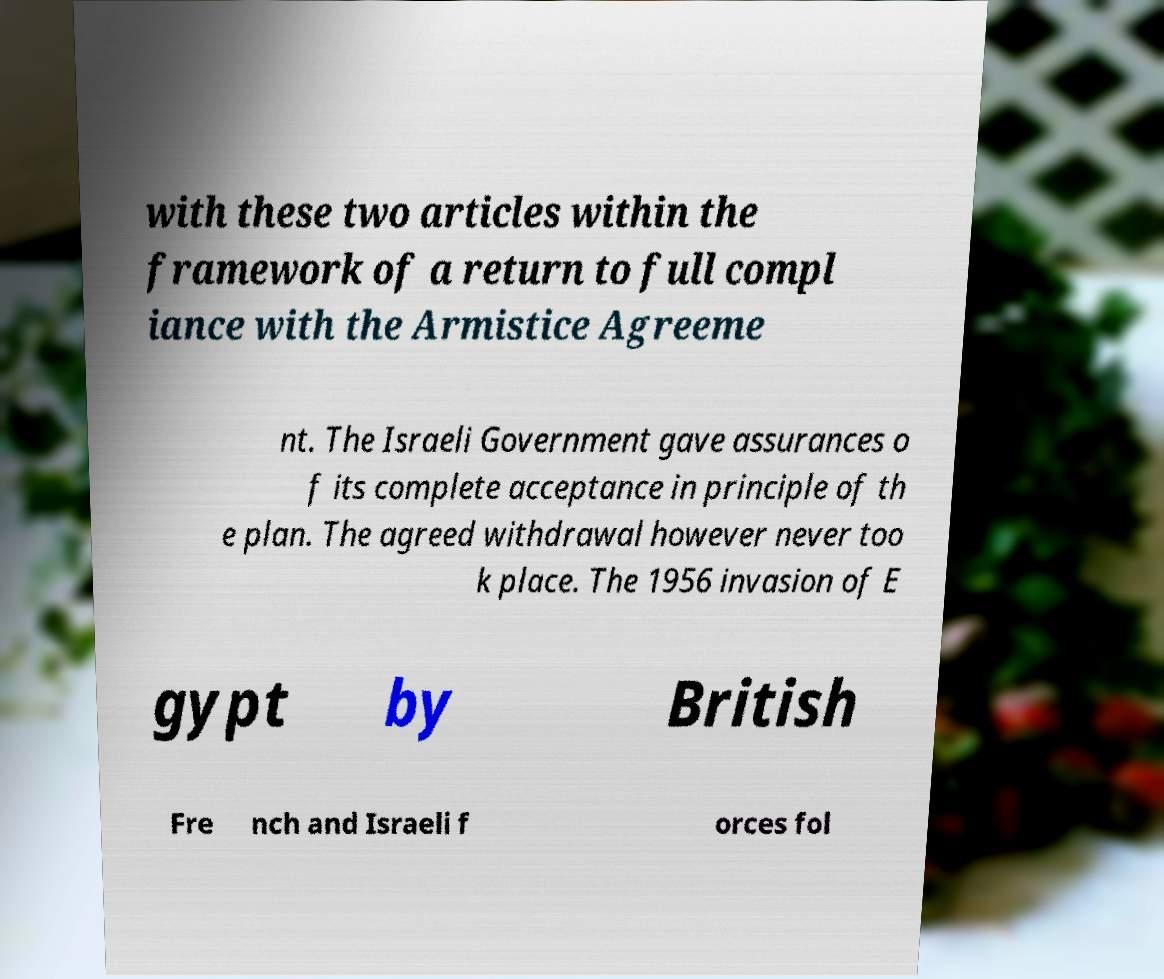I need the written content from this picture converted into text. Can you do that? with these two articles within the framework of a return to full compl iance with the Armistice Agreeme nt. The Israeli Government gave assurances o f its complete acceptance in principle of th e plan. The agreed withdrawal however never too k place. The 1956 invasion of E gypt by British Fre nch and Israeli f orces fol 